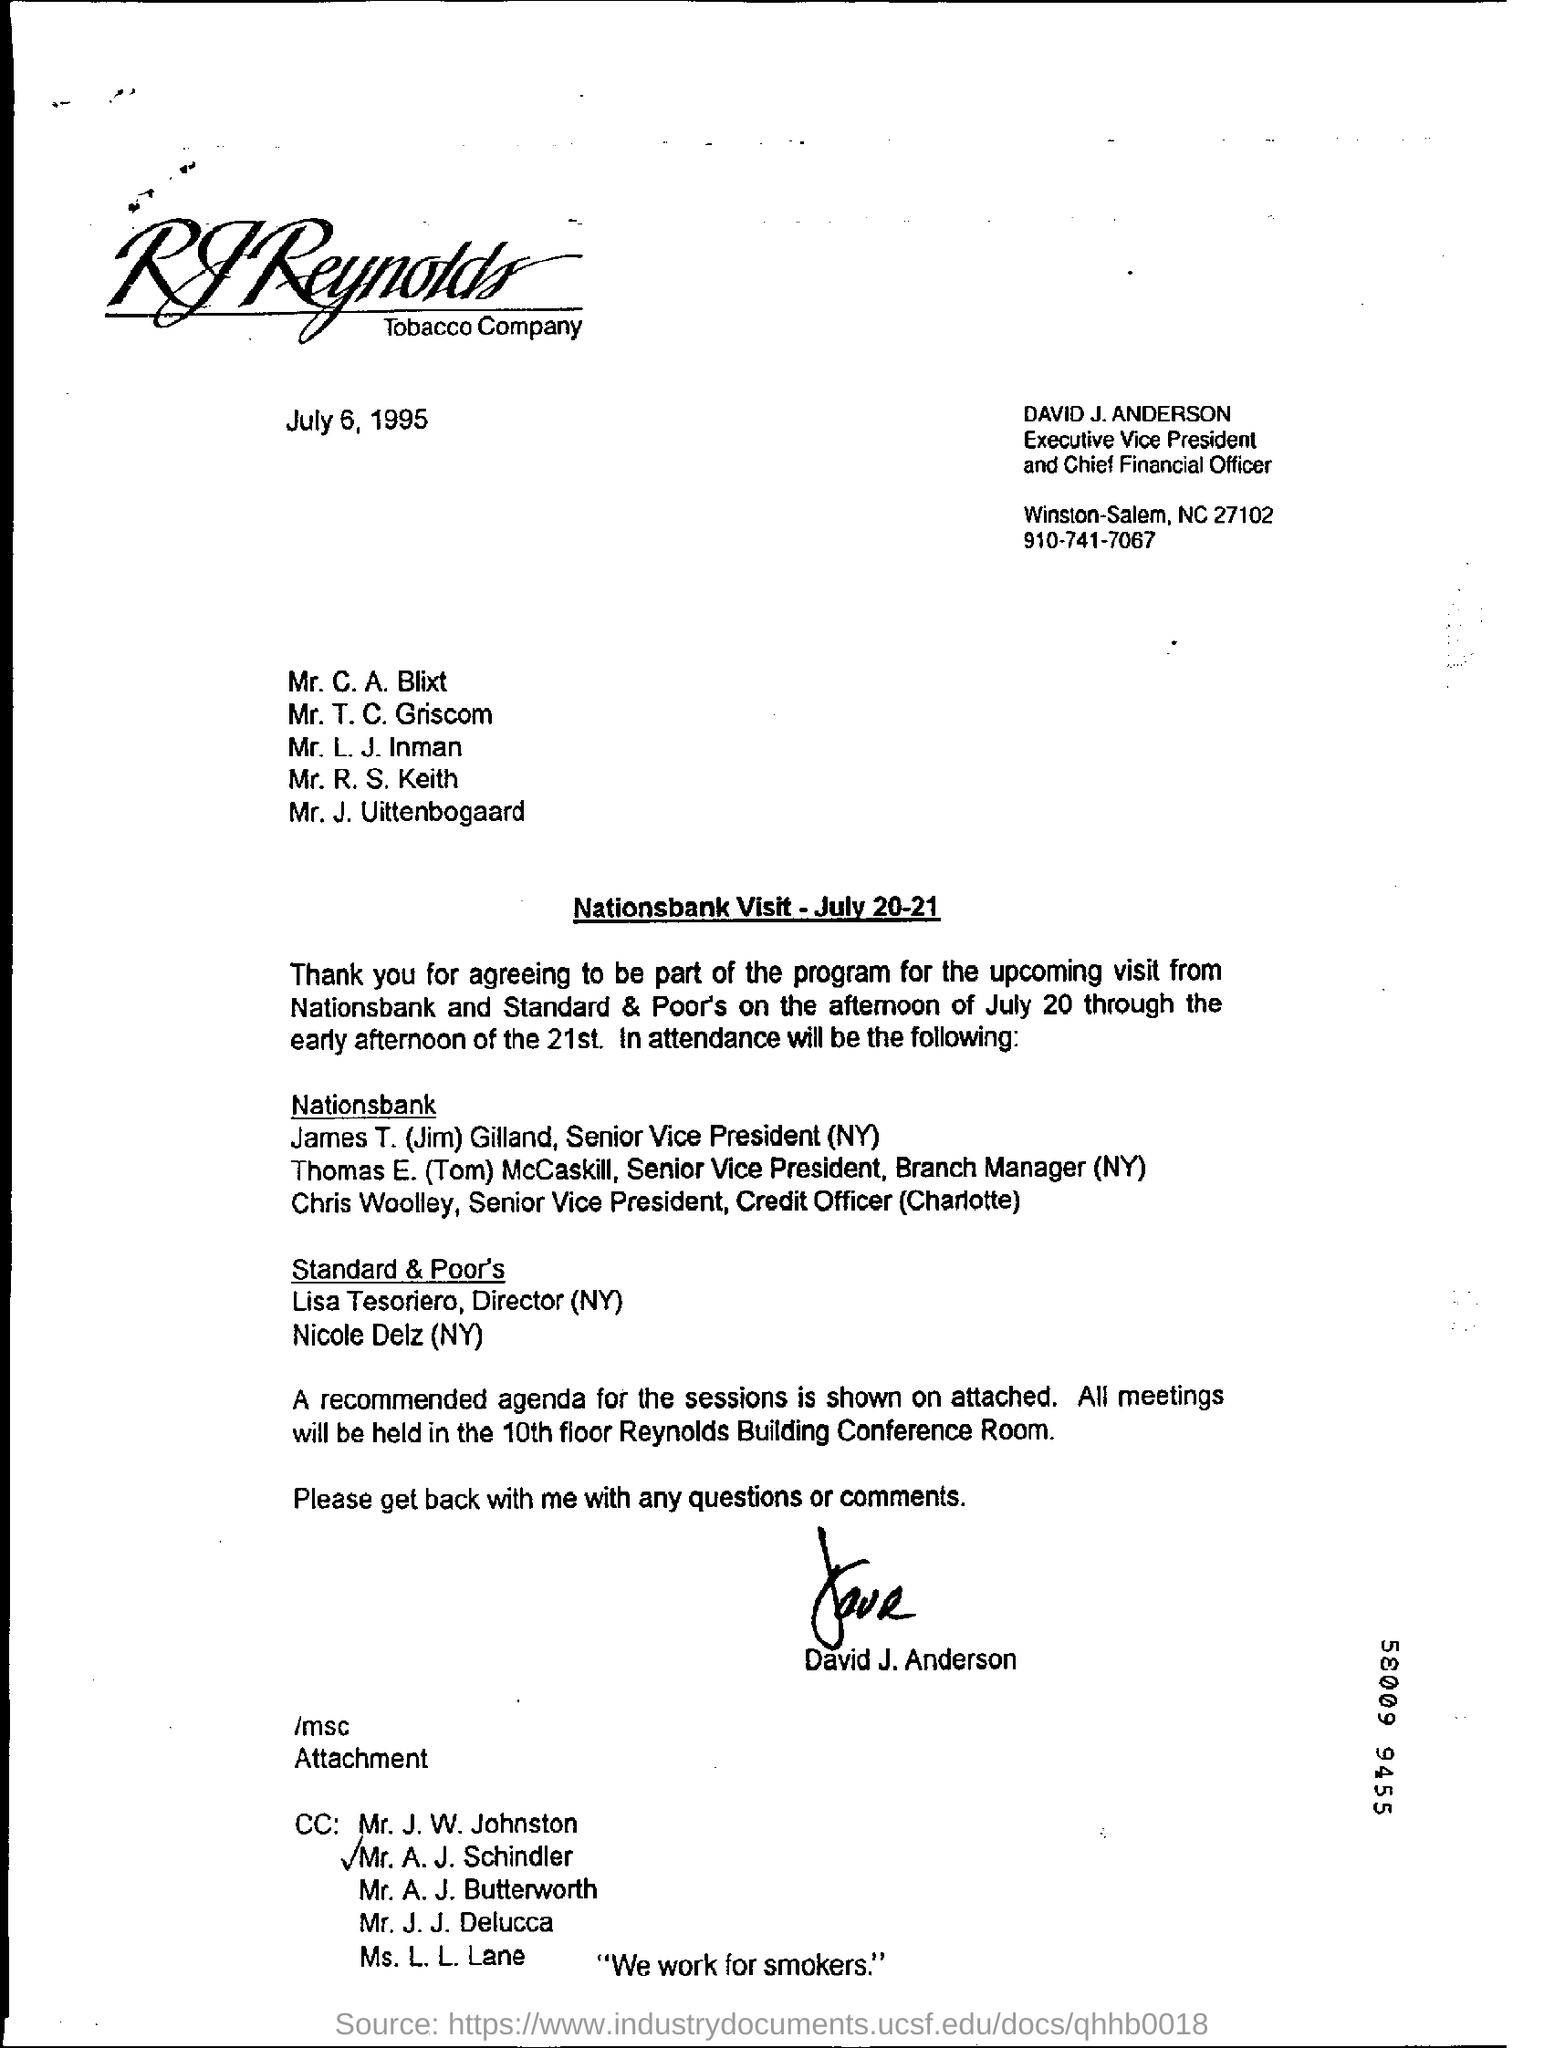Who is DAVID J. ANDERSON?
Offer a very short reply. Executive Vice President and Chief Financial Officer. Who is the Senior Vice President(NY) of Nationsbank?
Make the answer very short. James T. (Jim) Gilland. Who has signed the document?
Offer a terse response. David J. Anderson. In which place, the meetings are held?
Your answer should be very brief. 10th floor Reynolds Building Conference Room. What is the issued date of this document?
Your answer should be compact. July 6, 1995. 